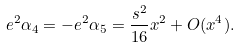Convert formula to latex. <formula><loc_0><loc_0><loc_500><loc_500>e ^ { 2 } \alpha _ { 4 } = - e ^ { 2 } \alpha _ { 5 } = \frac { s ^ { 2 } } { 1 6 } x ^ { 2 } + O ( x ^ { 4 } ) .</formula> 